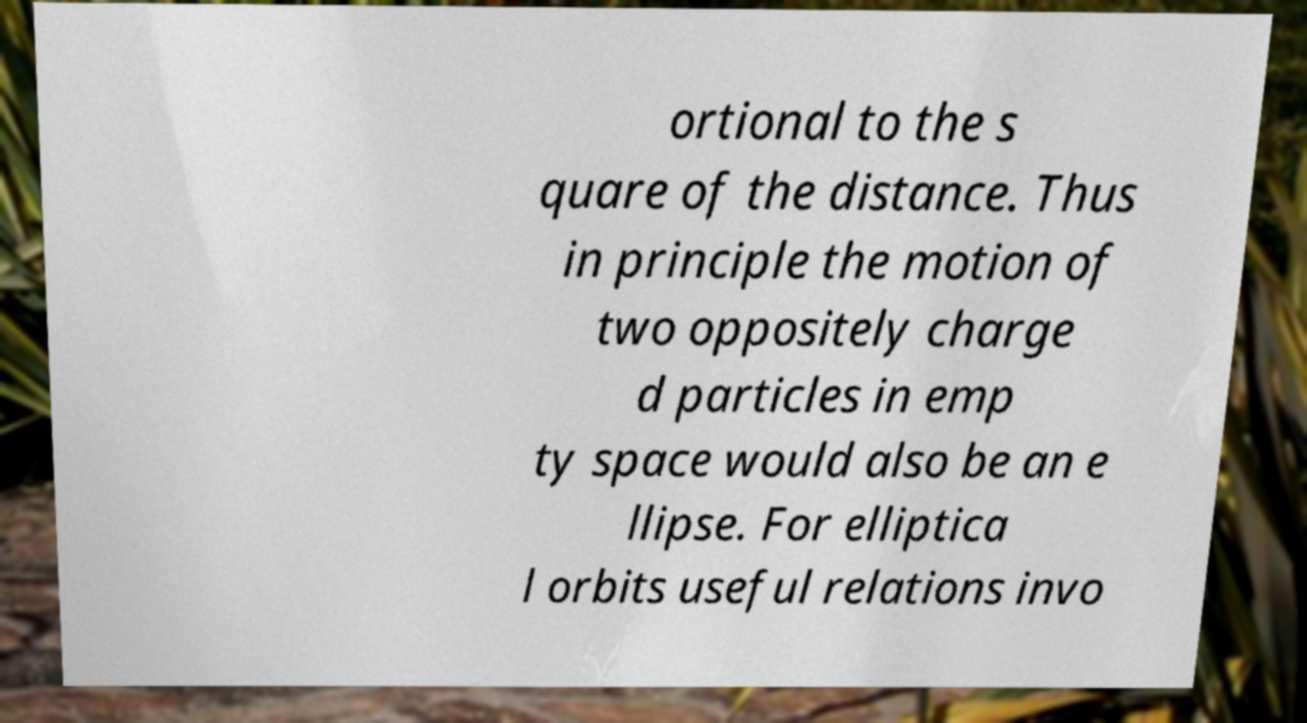What messages or text are displayed in this image? I need them in a readable, typed format. ortional to the s quare of the distance. Thus in principle the motion of two oppositely charge d particles in emp ty space would also be an e llipse. For elliptica l orbits useful relations invo 